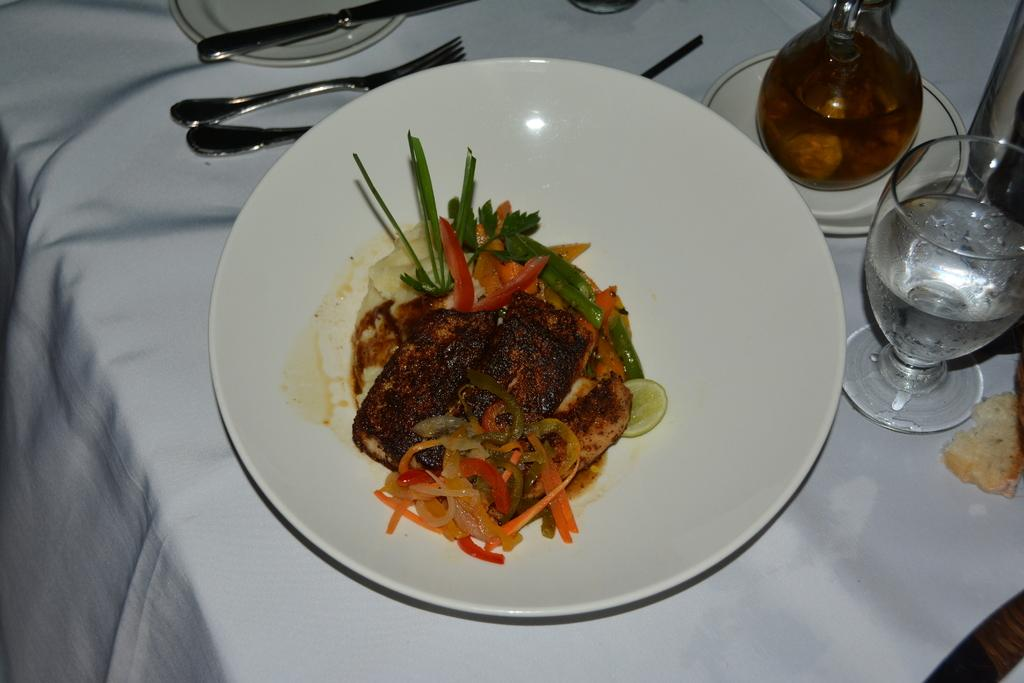What is on the plate that is visible in the image? There is a plate with food in the image. What utensils are present in the image? There is a fork, a glass, and a knife in the image. What other objects can be seen on the table in the image? There are other objects on the table in the image, but their specific details are not mentioned in the provided facts. What type of stick can be seen being used to stitch the oatmeal in the image? There is no stick, stitching, or oatmeal present in the image. 